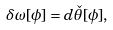<formula> <loc_0><loc_0><loc_500><loc_500>\delta \omega [ \phi ] = d \check { \theta } [ \phi ] ,</formula> 